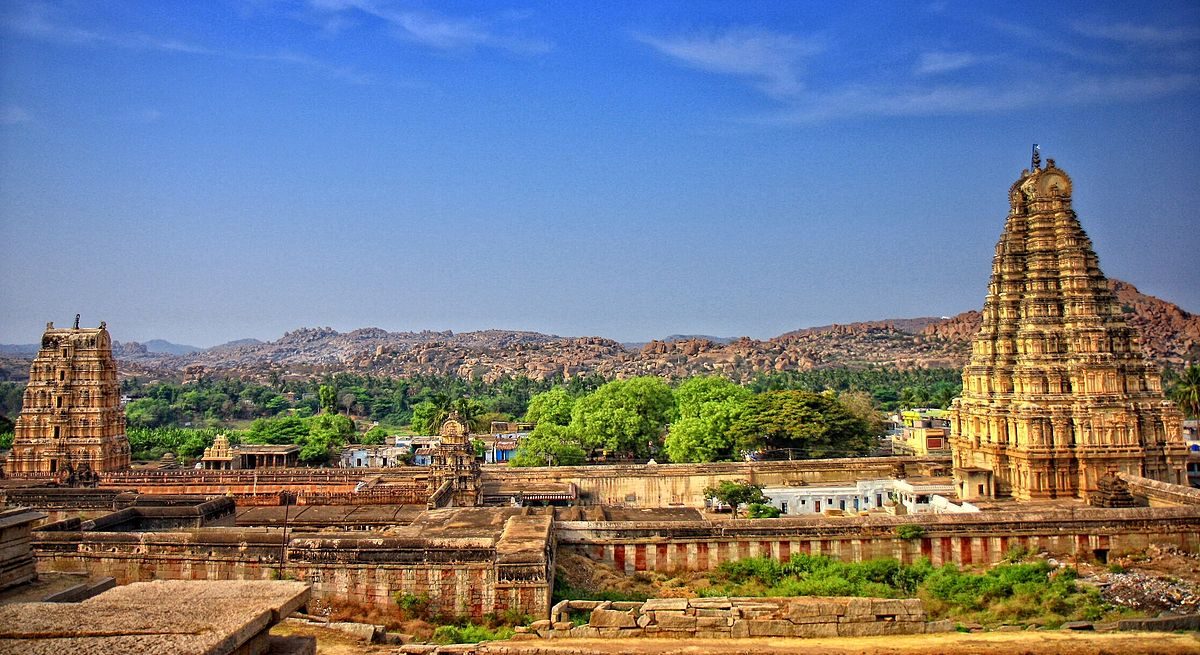Can you describe any historical events associated with the Virupaksha Temple? The Virupaksha Temple is steeped in history, initially a small shrine that transformed into a large complex under the Vijayanagara rulers in the 14th to the 16th centuries. It has withstood the ebb and flow of time, particularly the siege of Hampi in 1565, after which Hampi was abandoned and fell to ruin, though the temple remains an active site of worship. Over the centuries, it has been a witness to the grandeur of the Vijayanagara Empire, the cultural and religious ceremonies that have drawn pilgrims for hundreds of years, and the various restoration projects undertaken to preserve it for future generations. 